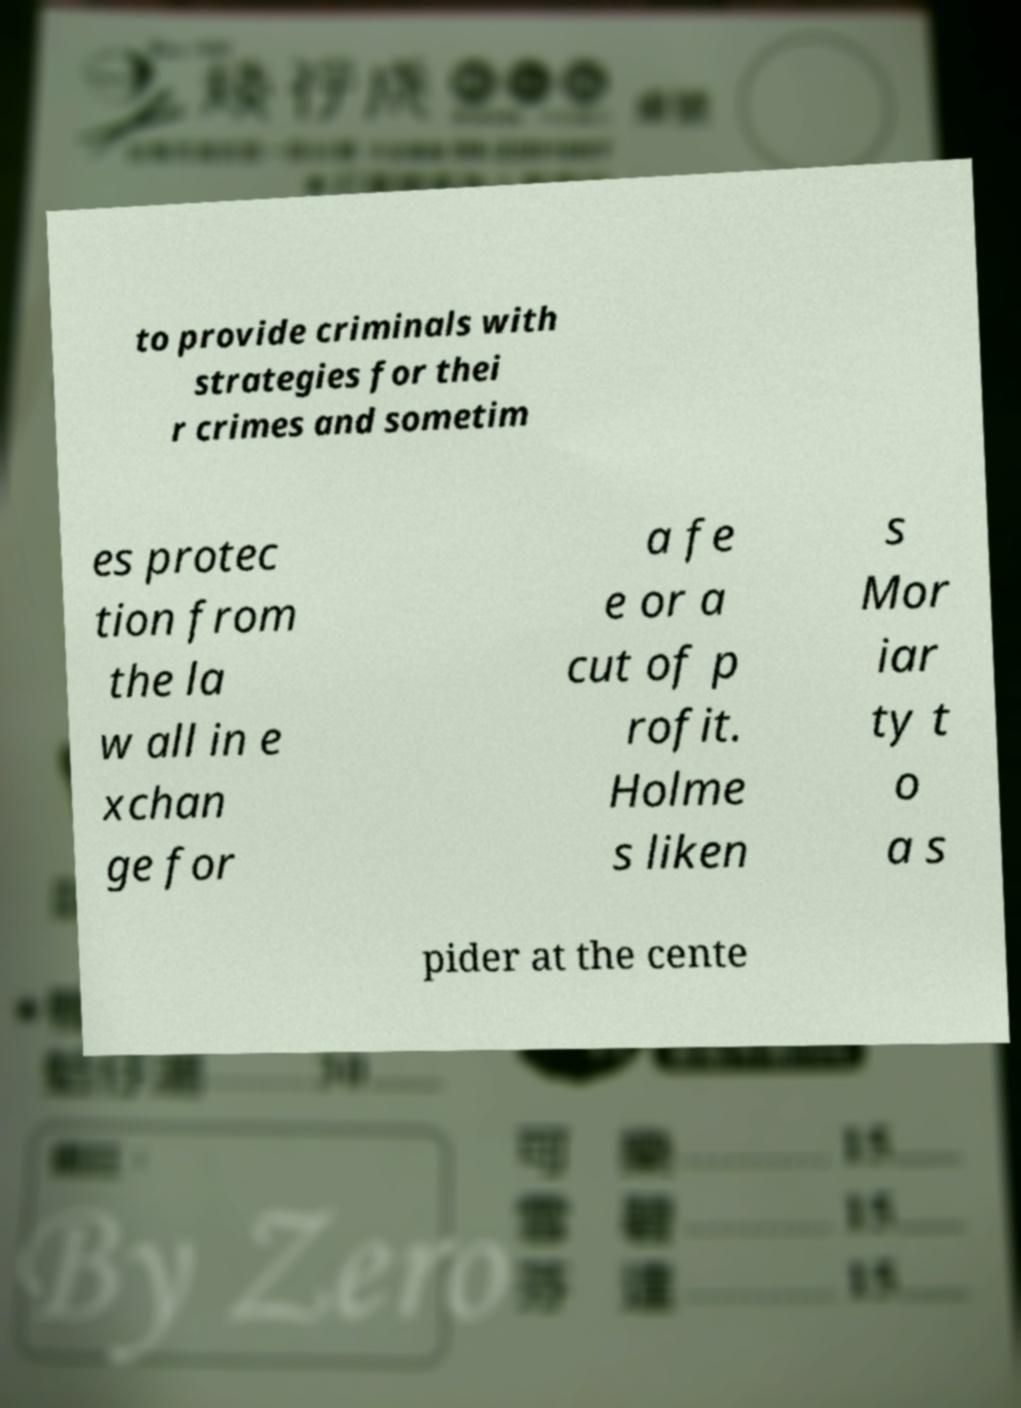There's text embedded in this image that I need extracted. Can you transcribe it verbatim? to provide criminals with strategies for thei r crimes and sometim es protec tion from the la w all in e xchan ge for a fe e or a cut of p rofit. Holme s liken s Mor iar ty t o a s pider at the cente 